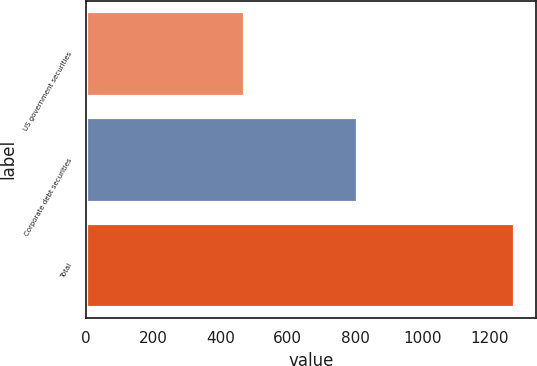<chart> <loc_0><loc_0><loc_500><loc_500><bar_chart><fcel>US government securities<fcel>Corporate debt securities<fcel>Total<nl><fcel>469<fcel>805<fcel>1274<nl></chart> 